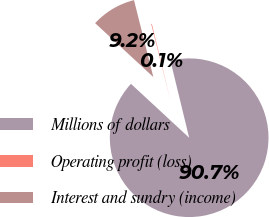<chart> <loc_0><loc_0><loc_500><loc_500><pie_chart><fcel>Millions of dollars<fcel>Operating profit (loss)<fcel>Interest and sundry (income)<nl><fcel>90.68%<fcel>0.13%<fcel>9.19%<nl></chart> 